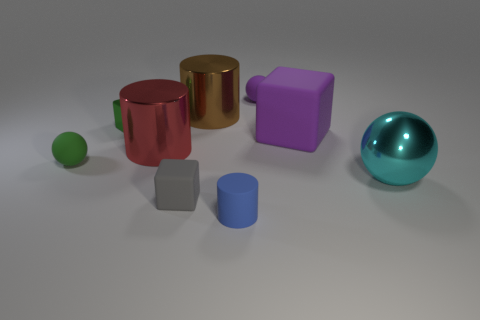Are there any other things that are the same size as the green matte sphere?
Provide a succinct answer. Yes. There is a shiny thing that is the same shape as the small gray rubber thing; what size is it?
Offer a terse response. Small. The big thing that is the same shape as the tiny purple object is what color?
Give a very brief answer. Cyan. How many large blocks are the same color as the tiny rubber cylinder?
Provide a short and direct response. 0. There is a big object that is on the right side of the big cube; is it the same shape as the red metallic thing?
Give a very brief answer. No. What shape is the tiny matte thing that is behind the brown cylinder that is behind the big shiny thing that is right of the large purple cube?
Make the answer very short. Sphere. How big is the gray rubber thing?
Ensure brevity in your answer.  Small. There is a cylinder that is made of the same material as the tiny gray object; what is its color?
Your answer should be compact. Blue. How many small green objects are the same material as the tiny blue cylinder?
Offer a very short reply. 1. Is the color of the big matte cube the same as the tiny matte sphere right of the small gray block?
Ensure brevity in your answer.  Yes. 